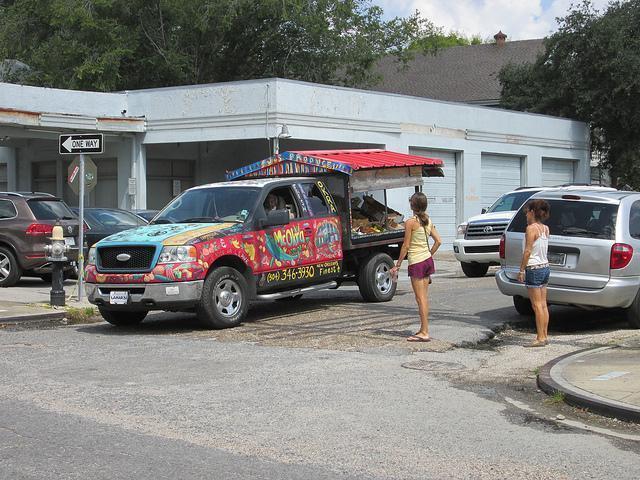How many people are there?
Give a very brief answer. 2. How many trucks are in the photo?
Give a very brief answer. 2. How many cars are there?
Give a very brief answer. 2. How many motor vehicles have orange paint?
Give a very brief answer. 0. 